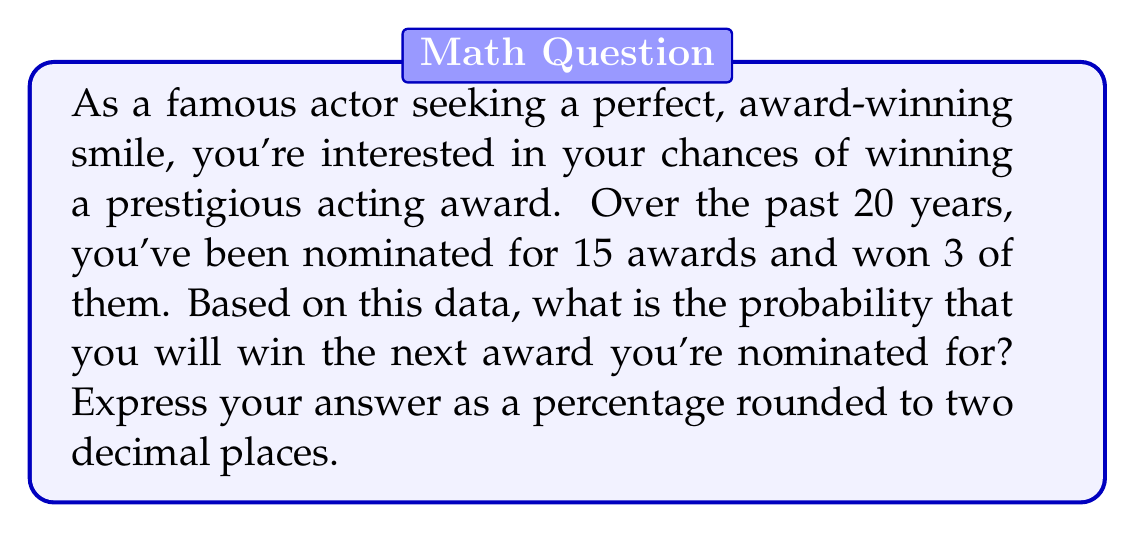Help me with this question. To calculate the probability of winning an award based on past data, we'll use the concept of relative frequency as an estimate of probability.

1) First, let's identify the relevant information:
   - Total nominations: 15
   - Total wins: 3

2) The probability of winning can be calculated using the formula:

   $$P(\text{winning}) = \frac{\text{number of favorable outcomes}}{\text{total number of possible outcomes}}$$

3) In this case:
   $$P(\text{winning}) = \frac{\text{number of wins}}{\text{total number of nominations}}$$

4) Substituting the values:
   $$P(\text{winning}) = \frac{3}{15}$$

5) Simplify the fraction:
   $$P(\text{winning}) = \frac{1}{5} = 0.2$$

6) Convert to a percentage:
   $$0.2 \times 100\% = 20\%$$

Therefore, based on your past performance, the probability of winning your next nominated award is 20%.
Answer: 20.00% 